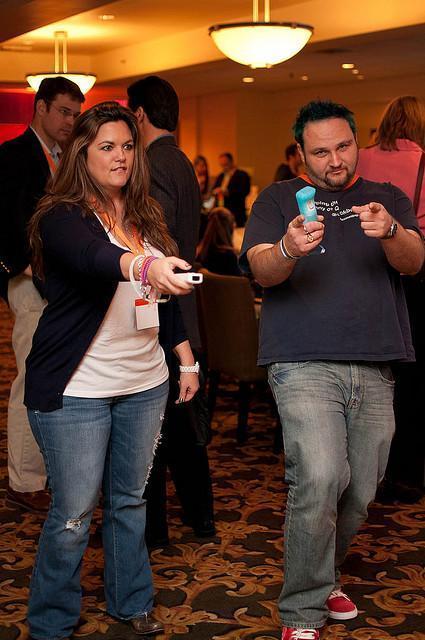How many people are in the picture?
Give a very brief answer. 6. 